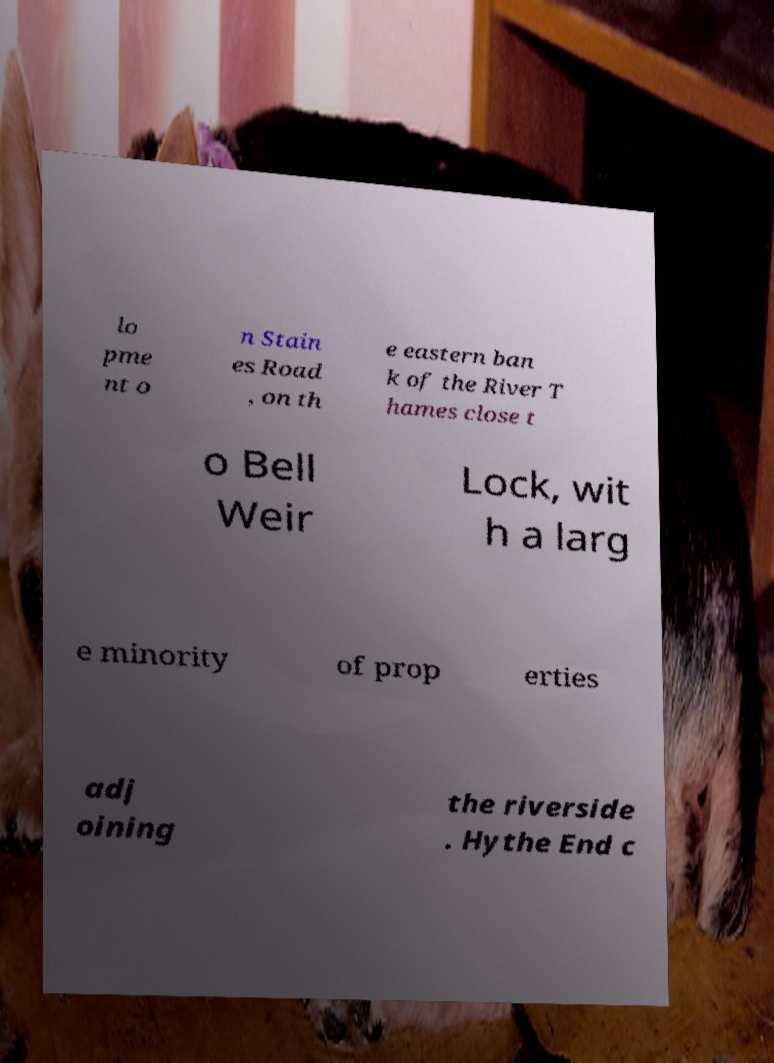Could you extract and type out the text from this image? lo pme nt o n Stain es Road , on th e eastern ban k of the River T hames close t o Bell Weir Lock, wit h a larg e minority of prop erties adj oining the riverside . Hythe End c 